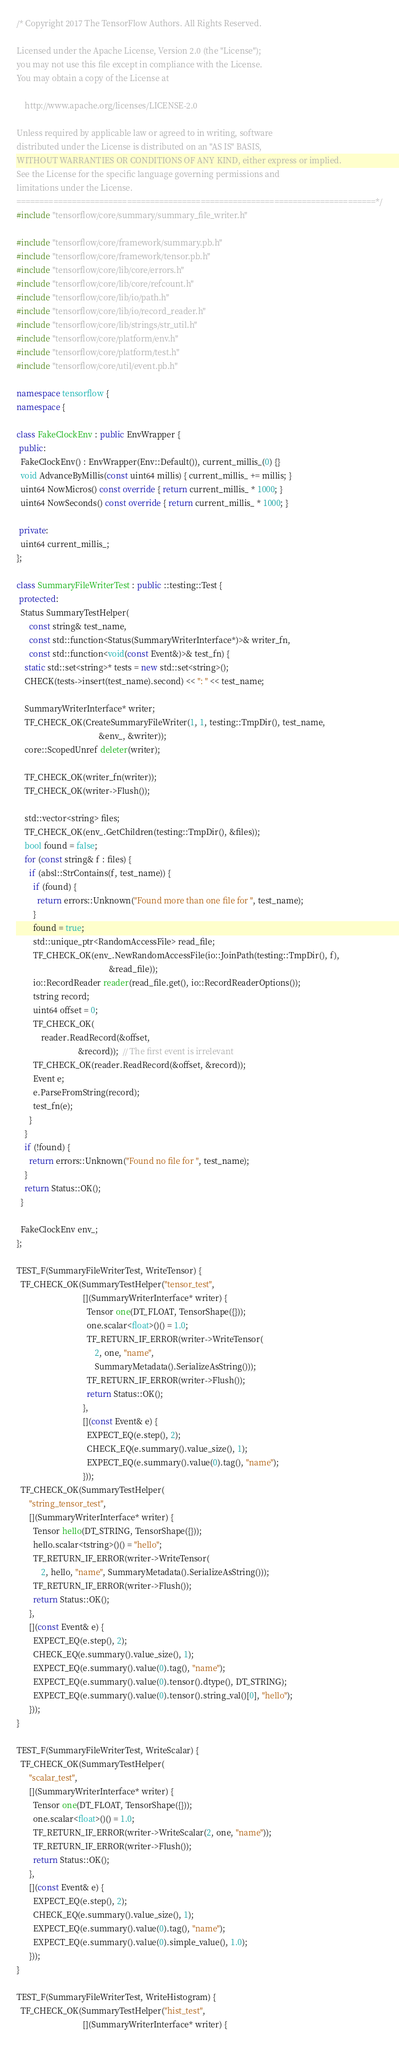Convert code to text. <code><loc_0><loc_0><loc_500><loc_500><_C++_>/* Copyright 2017 The TensorFlow Authors. All Rights Reserved.

Licensed under the Apache License, Version 2.0 (the "License");
you may not use this file except in compliance with the License.
You may obtain a copy of the License at

    http://www.apache.org/licenses/LICENSE-2.0

Unless required by applicable law or agreed to in writing, software
distributed under the License is distributed on an "AS IS" BASIS,
WITHOUT WARRANTIES OR CONDITIONS OF ANY KIND, either express or implied.
See the License for the specific language governing permissions and
limitations under the License.
==============================================================================*/
#include "tensorflow/core/summary/summary_file_writer.h"

#include "tensorflow/core/framework/summary.pb.h"
#include "tensorflow/core/framework/tensor.pb.h"
#include "tensorflow/core/lib/core/errors.h"
#include "tensorflow/core/lib/core/refcount.h"
#include "tensorflow/core/lib/io/path.h"
#include "tensorflow/core/lib/io/record_reader.h"
#include "tensorflow/core/lib/strings/str_util.h"
#include "tensorflow/core/platform/env.h"
#include "tensorflow/core/platform/test.h"
#include "tensorflow/core/util/event.pb.h"

namespace tensorflow {
namespace {

class FakeClockEnv : public EnvWrapper {
 public:
  FakeClockEnv() : EnvWrapper(Env::Default()), current_millis_(0) {}
  void AdvanceByMillis(const uint64 millis) { current_millis_ += millis; }
  uint64 NowMicros() const override { return current_millis_ * 1000; }
  uint64 NowSeconds() const override { return current_millis_ * 1000; }

 private:
  uint64 current_millis_;
};

class SummaryFileWriterTest : public ::testing::Test {
 protected:
  Status SummaryTestHelper(
      const string& test_name,
      const std::function<Status(SummaryWriterInterface*)>& writer_fn,
      const std::function<void(const Event&)>& test_fn) {
    static std::set<string>* tests = new std::set<string>();
    CHECK(tests->insert(test_name).second) << ": " << test_name;

    SummaryWriterInterface* writer;
    TF_CHECK_OK(CreateSummaryFileWriter(1, 1, testing::TmpDir(), test_name,
                                        &env_, &writer));
    core::ScopedUnref deleter(writer);

    TF_CHECK_OK(writer_fn(writer));
    TF_CHECK_OK(writer->Flush());

    std::vector<string> files;
    TF_CHECK_OK(env_.GetChildren(testing::TmpDir(), &files));
    bool found = false;
    for (const string& f : files) {
      if (absl::StrContains(f, test_name)) {
        if (found) {
          return errors::Unknown("Found more than one file for ", test_name);
        }
        found = true;
        std::unique_ptr<RandomAccessFile> read_file;
        TF_CHECK_OK(env_.NewRandomAccessFile(io::JoinPath(testing::TmpDir(), f),
                                             &read_file));
        io::RecordReader reader(read_file.get(), io::RecordReaderOptions());
        tstring record;
        uint64 offset = 0;
        TF_CHECK_OK(
            reader.ReadRecord(&offset,
                              &record));  // The first event is irrelevant
        TF_CHECK_OK(reader.ReadRecord(&offset, &record));
        Event e;
        e.ParseFromString(record);
        test_fn(e);
      }
    }
    if (!found) {
      return errors::Unknown("Found no file for ", test_name);
    }
    return Status::OK();
  }

  FakeClockEnv env_;
};

TEST_F(SummaryFileWriterTest, WriteTensor) {
  TF_CHECK_OK(SummaryTestHelper("tensor_test",
                                [](SummaryWriterInterface* writer) {
                                  Tensor one(DT_FLOAT, TensorShape({}));
                                  one.scalar<float>()() = 1.0;
                                  TF_RETURN_IF_ERROR(writer->WriteTensor(
                                      2, one, "name",
                                      SummaryMetadata().SerializeAsString()));
                                  TF_RETURN_IF_ERROR(writer->Flush());
                                  return Status::OK();
                                },
                                [](const Event& e) {
                                  EXPECT_EQ(e.step(), 2);
                                  CHECK_EQ(e.summary().value_size(), 1);
                                  EXPECT_EQ(e.summary().value(0).tag(), "name");
                                }));
  TF_CHECK_OK(SummaryTestHelper(
      "string_tensor_test",
      [](SummaryWriterInterface* writer) {
        Tensor hello(DT_STRING, TensorShape({}));
        hello.scalar<tstring>()() = "hello";
        TF_RETURN_IF_ERROR(writer->WriteTensor(
            2, hello, "name", SummaryMetadata().SerializeAsString()));
        TF_RETURN_IF_ERROR(writer->Flush());
        return Status::OK();
      },
      [](const Event& e) {
        EXPECT_EQ(e.step(), 2);
        CHECK_EQ(e.summary().value_size(), 1);
        EXPECT_EQ(e.summary().value(0).tag(), "name");
        EXPECT_EQ(e.summary().value(0).tensor().dtype(), DT_STRING);
        EXPECT_EQ(e.summary().value(0).tensor().string_val()[0], "hello");
      }));
}

TEST_F(SummaryFileWriterTest, WriteScalar) {
  TF_CHECK_OK(SummaryTestHelper(
      "scalar_test",
      [](SummaryWriterInterface* writer) {
        Tensor one(DT_FLOAT, TensorShape({}));
        one.scalar<float>()() = 1.0;
        TF_RETURN_IF_ERROR(writer->WriteScalar(2, one, "name"));
        TF_RETURN_IF_ERROR(writer->Flush());
        return Status::OK();
      },
      [](const Event& e) {
        EXPECT_EQ(e.step(), 2);
        CHECK_EQ(e.summary().value_size(), 1);
        EXPECT_EQ(e.summary().value(0).tag(), "name");
        EXPECT_EQ(e.summary().value(0).simple_value(), 1.0);
      }));
}

TEST_F(SummaryFileWriterTest, WriteHistogram) {
  TF_CHECK_OK(SummaryTestHelper("hist_test",
                                [](SummaryWriterInterface* writer) {</code> 